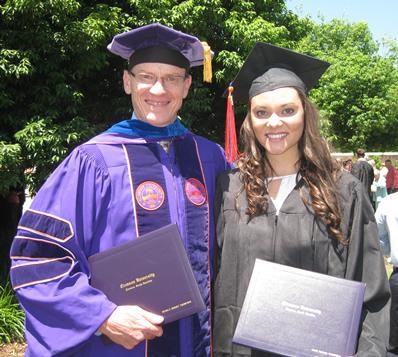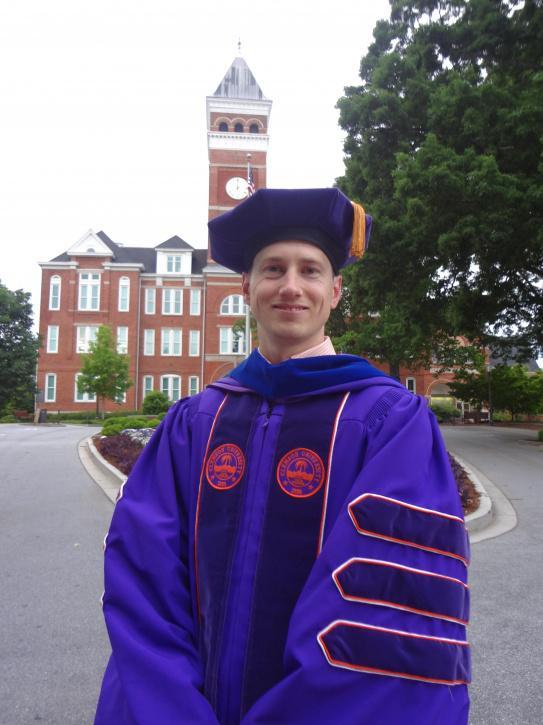The first image is the image on the left, the second image is the image on the right. Assess this claim about the two images: "One image includes at least two female graduates wearing black caps and robes with orange sashes, and the other image shows only one person in a graduate robe in the foreground.". Correct or not? Answer yes or no. No. The first image is the image on the left, the second image is the image on the right. Given the left and right images, does the statement "There are at least two women wearing orange sashes." hold true? Answer yes or no. No. 